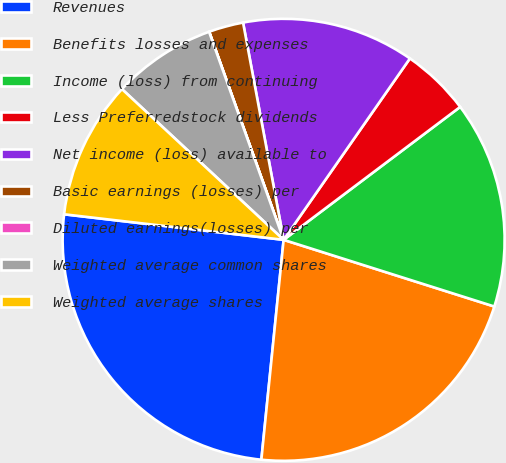Convert chart to OTSL. <chart><loc_0><loc_0><loc_500><loc_500><pie_chart><fcel>Revenues<fcel>Benefits losses and expenses<fcel>Income (loss) from continuing<fcel>Less Preferredstock dividends<fcel>Net income (loss) available to<fcel>Basic earnings (losses) per<fcel>Diluted earnings(losses) per<fcel>Weighted average common shares<fcel>Weighted average shares<nl><fcel>25.24%<fcel>21.73%<fcel>15.15%<fcel>5.05%<fcel>12.62%<fcel>2.53%<fcel>0.01%<fcel>7.58%<fcel>10.1%<nl></chart> 